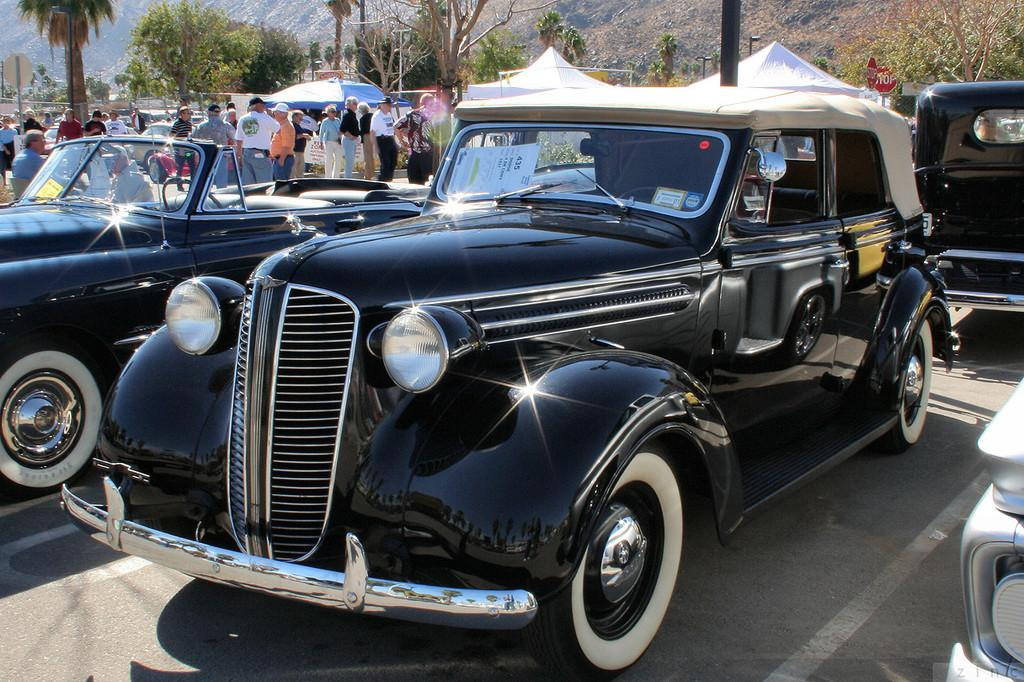What types of objects are present in the image? There are vehicles, a group of people, a tent, trees, poles, and a mountain in the image. Can you describe the setting of the image? The image features a mountain, trees, and a road at the bottom, suggesting an outdoor setting. What might the group of people be doing in the image? The group of people could be camping, as there is a tent present in the image. What is the purpose of the poles in the image? The poles might be used for supporting the tent or other structures in the image. Where is the cow located in the image? There is no cow present in the image. What type of animals can be seen at the zoo in the image? There is no zoo present in the image. 